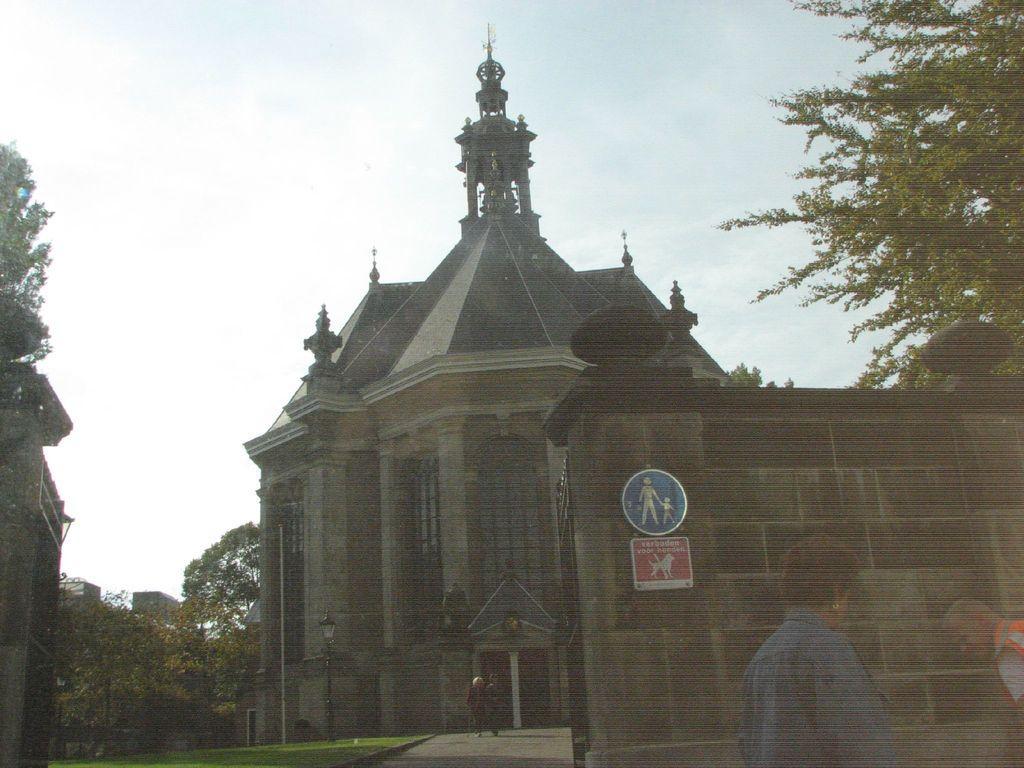Please provide a concise description of this image. In the picture we can see the palace and near to it we can see a grass surface and beside it we can see a path and on it we can see two people are walking and near to it we can see a two walls with gates opened and outside the wall we can see two people are standing and behind the palace we can see some trees and the sky with clouds. 